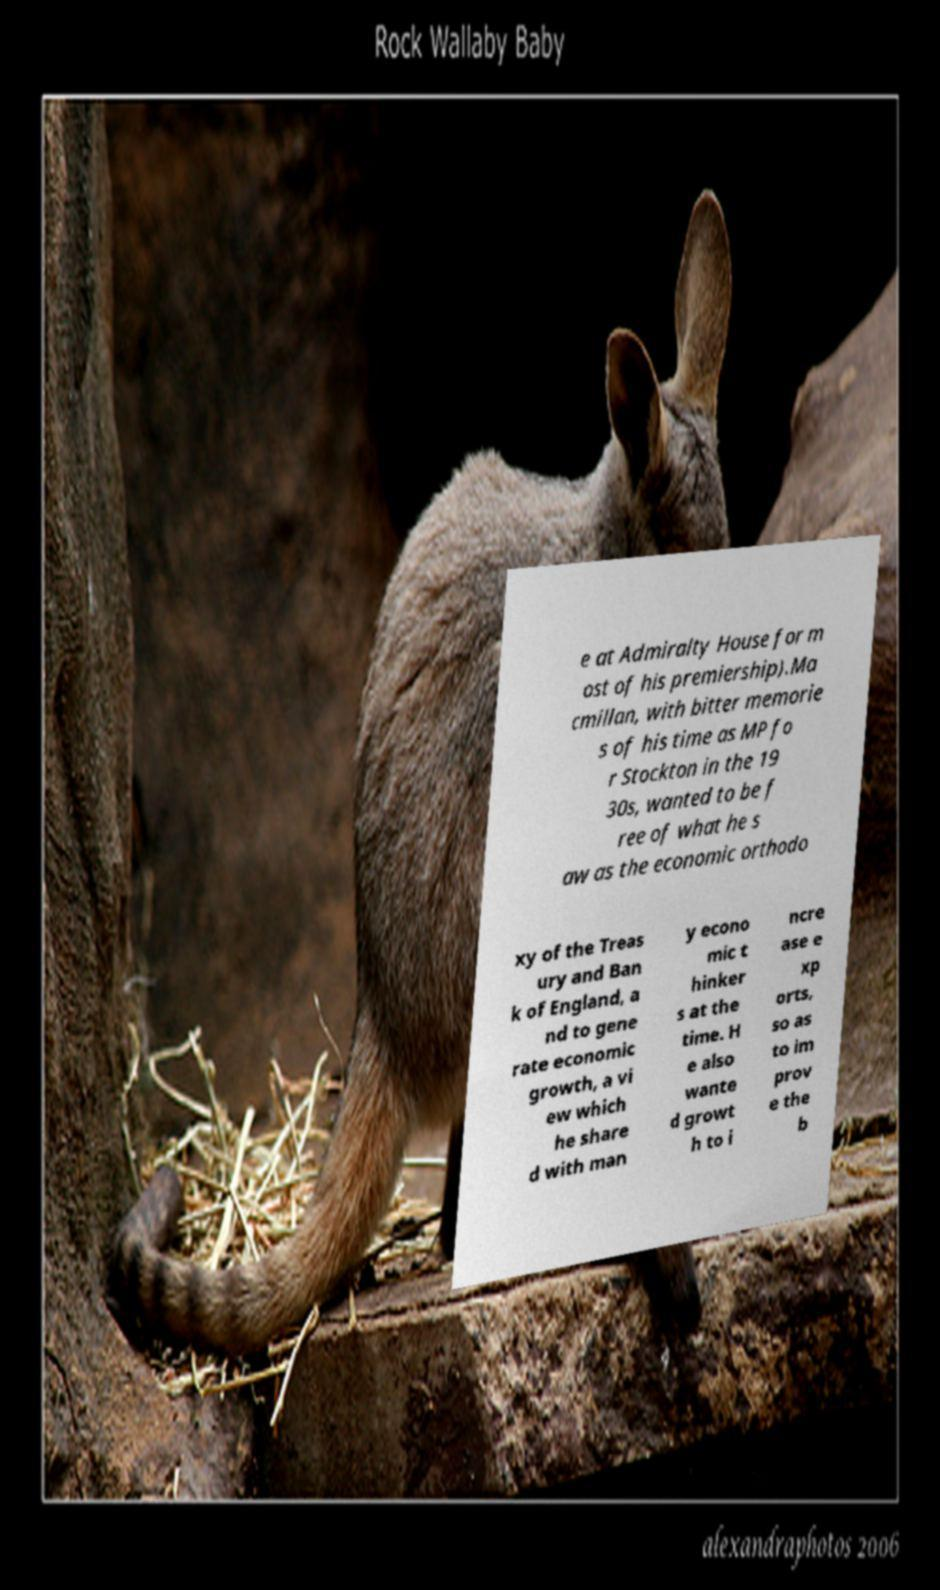Could you assist in decoding the text presented in this image and type it out clearly? e at Admiralty House for m ost of his premiership).Ma cmillan, with bitter memorie s of his time as MP fo r Stockton in the 19 30s, wanted to be f ree of what he s aw as the economic orthodo xy of the Treas ury and Ban k of England, a nd to gene rate economic growth, a vi ew which he share d with man y econo mic t hinker s at the time. H e also wante d growt h to i ncre ase e xp orts, so as to im prov e the b 